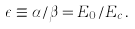Convert formula to latex. <formula><loc_0><loc_0><loc_500><loc_500>\epsilon \equiv \alpha / \beta = E _ { 0 } / E _ { c } \, .</formula> 